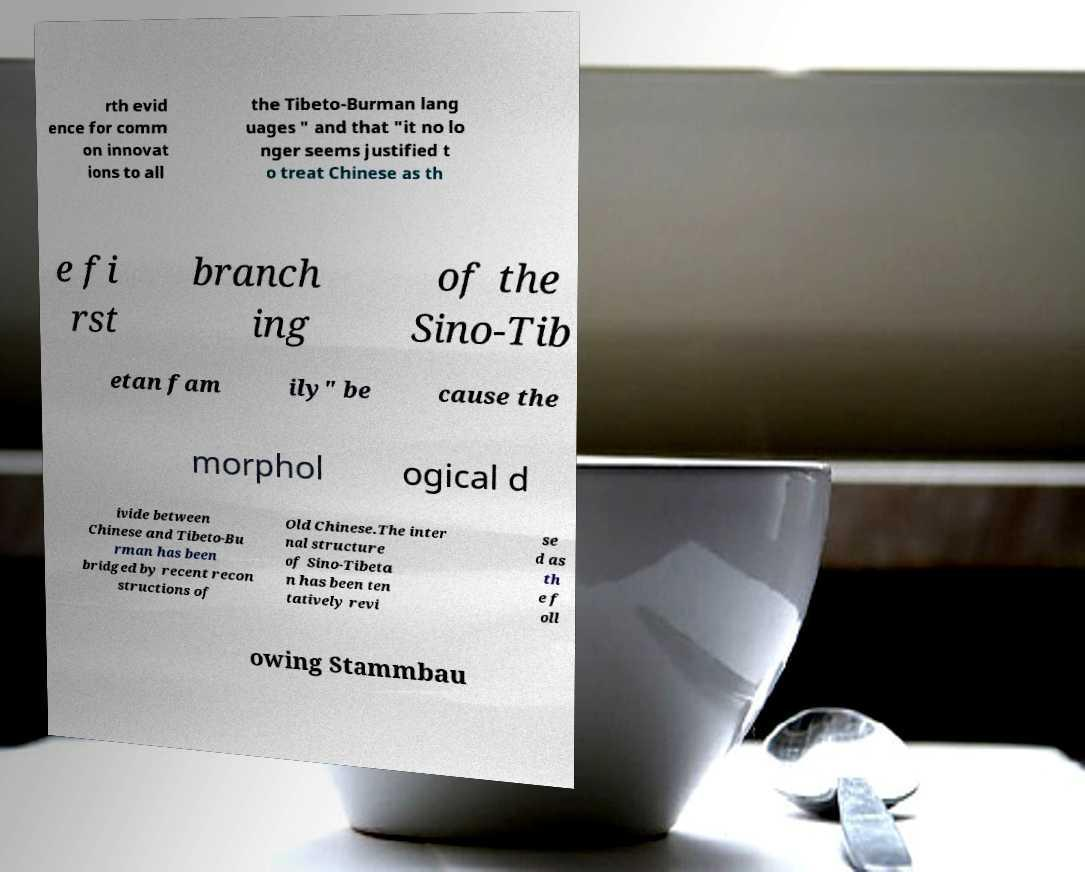Please identify and transcribe the text found in this image. rth evid ence for comm on innovat ions to all the Tibeto-Burman lang uages " and that "it no lo nger seems justified t o treat Chinese as th e fi rst branch ing of the Sino-Tib etan fam ily" be cause the morphol ogical d ivide between Chinese and Tibeto-Bu rman has been bridged by recent recon structions of Old Chinese.The inter nal structure of Sino-Tibeta n has been ten tatively revi se d as th e f oll owing Stammbau 